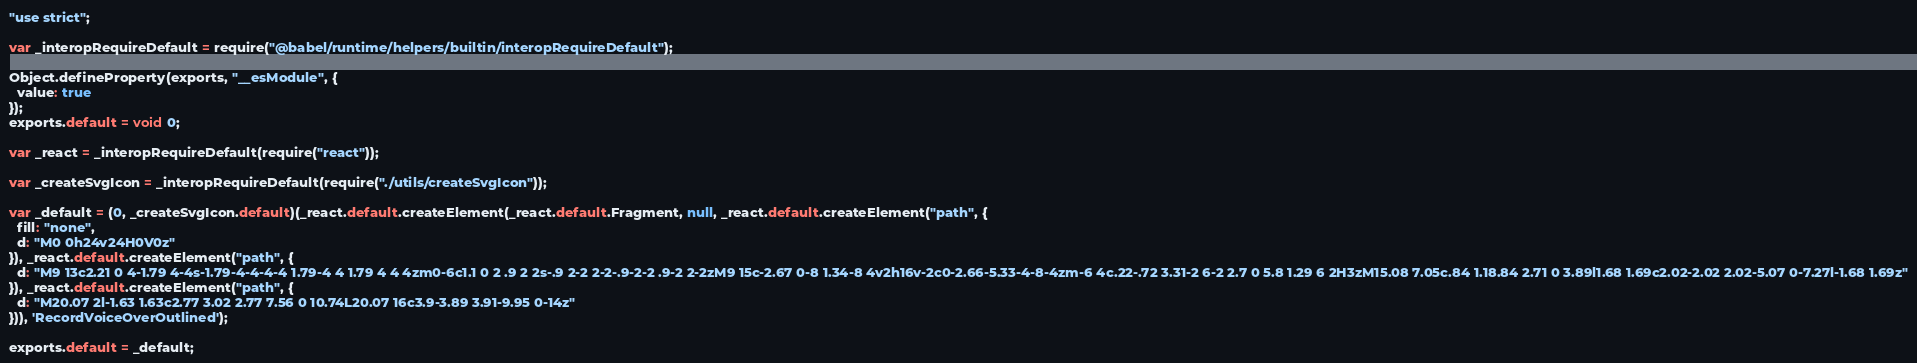Convert code to text. <code><loc_0><loc_0><loc_500><loc_500><_JavaScript_>"use strict";

var _interopRequireDefault = require("@babel/runtime/helpers/builtin/interopRequireDefault");

Object.defineProperty(exports, "__esModule", {
  value: true
});
exports.default = void 0;

var _react = _interopRequireDefault(require("react"));

var _createSvgIcon = _interopRequireDefault(require("./utils/createSvgIcon"));

var _default = (0, _createSvgIcon.default)(_react.default.createElement(_react.default.Fragment, null, _react.default.createElement("path", {
  fill: "none",
  d: "M0 0h24v24H0V0z"
}), _react.default.createElement("path", {
  d: "M9 13c2.21 0 4-1.79 4-4s-1.79-4-4-4-4 1.79-4 4 1.79 4 4 4zm0-6c1.1 0 2 .9 2 2s-.9 2-2 2-2-.9-2-2 .9-2 2-2zM9 15c-2.67 0-8 1.34-8 4v2h16v-2c0-2.66-5.33-4-8-4zm-6 4c.22-.72 3.31-2 6-2 2.7 0 5.8 1.29 6 2H3zM15.08 7.05c.84 1.18.84 2.71 0 3.89l1.68 1.69c2.02-2.02 2.02-5.07 0-7.27l-1.68 1.69z"
}), _react.default.createElement("path", {
  d: "M20.07 2l-1.63 1.63c2.77 3.02 2.77 7.56 0 10.74L20.07 16c3.9-3.89 3.91-9.95 0-14z"
})), 'RecordVoiceOverOutlined');

exports.default = _default;</code> 